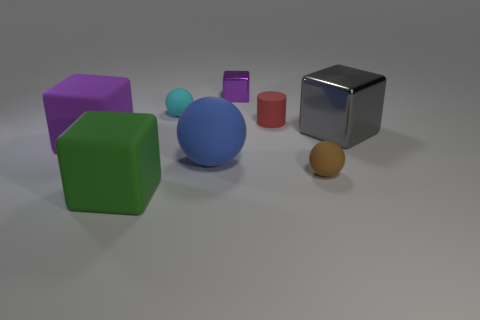Subtract all tiny purple cubes. How many cubes are left? 3 Add 1 green things. How many objects exist? 9 Subtract all gray cubes. How many cubes are left? 3 Subtract 1 cylinders. How many cylinders are left? 0 Subtract all yellow spheres. How many purple blocks are left? 2 Subtract all cylinders. How many objects are left? 7 Subtract all green blocks. Subtract all gray cylinders. How many blocks are left? 3 Subtract all big cubes. Subtract all large gray shiny cubes. How many objects are left? 4 Add 8 gray shiny objects. How many gray shiny objects are left? 9 Add 1 gray metallic cubes. How many gray metallic cubes exist? 2 